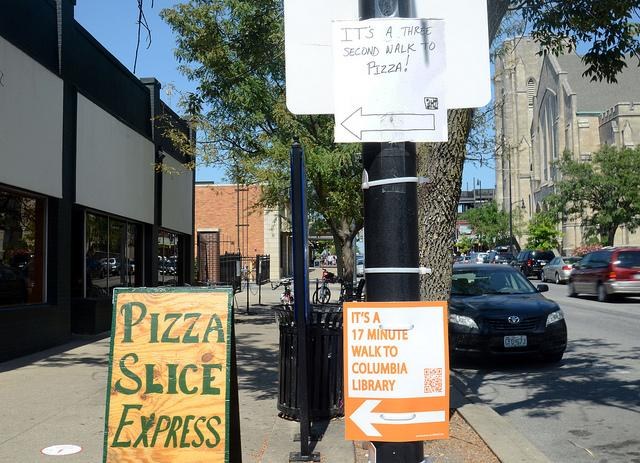What is the building across the street from the orange sign used for?

Choices:
A) education
B) business
C) religious services
D) government office religious services 